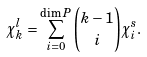<formula> <loc_0><loc_0><loc_500><loc_500>\chi ^ { l } _ { k } = \sum _ { i = 0 } ^ { \dim P } \binom { k - 1 } { i } \chi ^ { s } _ { i } .</formula> 